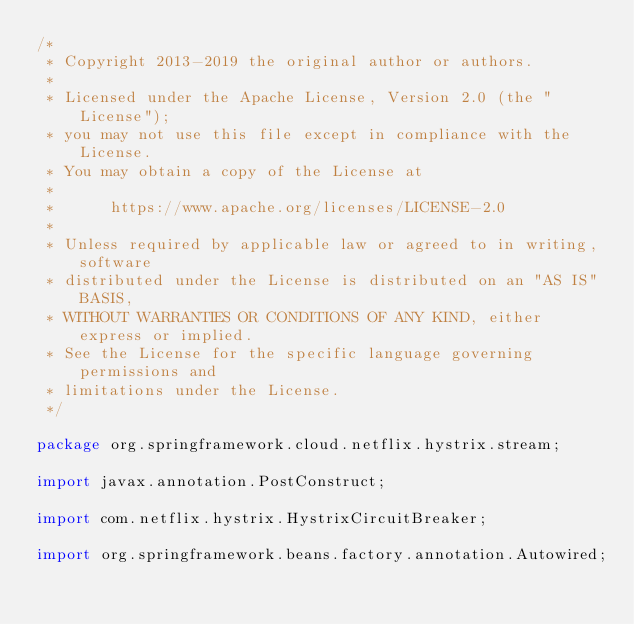Convert code to text. <code><loc_0><loc_0><loc_500><loc_500><_Java_>/*
 * Copyright 2013-2019 the original author or authors.
 *
 * Licensed under the Apache License, Version 2.0 (the "License");
 * you may not use this file except in compliance with the License.
 * You may obtain a copy of the License at
 *
 *      https://www.apache.org/licenses/LICENSE-2.0
 *
 * Unless required by applicable law or agreed to in writing, software
 * distributed under the License is distributed on an "AS IS" BASIS,
 * WITHOUT WARRANTIES OR CONDITIONS OF ANY KIND, either express or implied.
 * See the License for the specific language governing permissions and
 * limitations under the License.
 */

package org.springframework.cloud.netflix.hystrix.stream;

import javax.annotation.PostConstruct;

import com.netflix.hystrix.HystrixCircuitBreaker;

import org.springframework.beans.factory.annotation.Autowired;</code> 